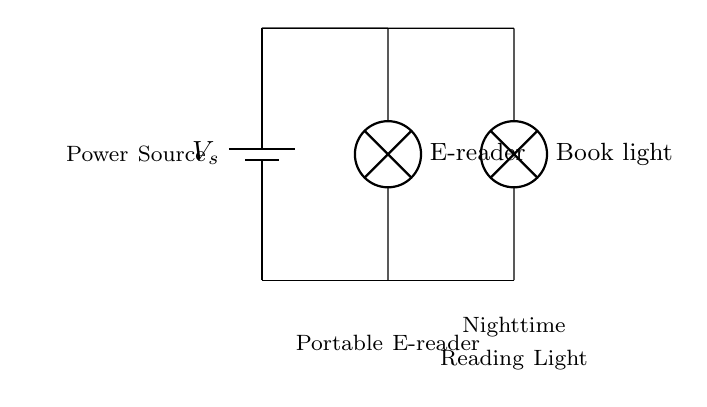What components are used in this circuit? The components in this circuit include a power source (battery) and two lamps (the e-reader and the book light). Each is connected in parallel, allowing them to operate independently while receiving the same voltage from the power source.
Answer: power source, e-reader, book light What type of circuit is shown here? The circuit is a parallel circuit where components (e-reader and book light) are connected alongside each other, allowing multiple devices to run independently from the same power source without affecting each other's operation.
Answer: parallel circuit How many branches are there in this circuit? There are two branches in this circuit, one for the e-reader and another for the book light. Each branch connects to the power source, enabling each lamp to function independently.
Answer: two branches What can you infer about the voltage across each lamp? In a parallel circuit, the voltage across each component is the same as the voltage supplied by the power source. Thus, each lamp experiences the full voltage supplied by the battery.
Answer: same as power source voltage How does the failure of one lamp affect the other? Since this is a parallel circuit, if one lamp (e-reader or book light) fails, the other lamp will continue to work because each lamp has its own independent path to the power source.
Answer: The other lamp remains operational 